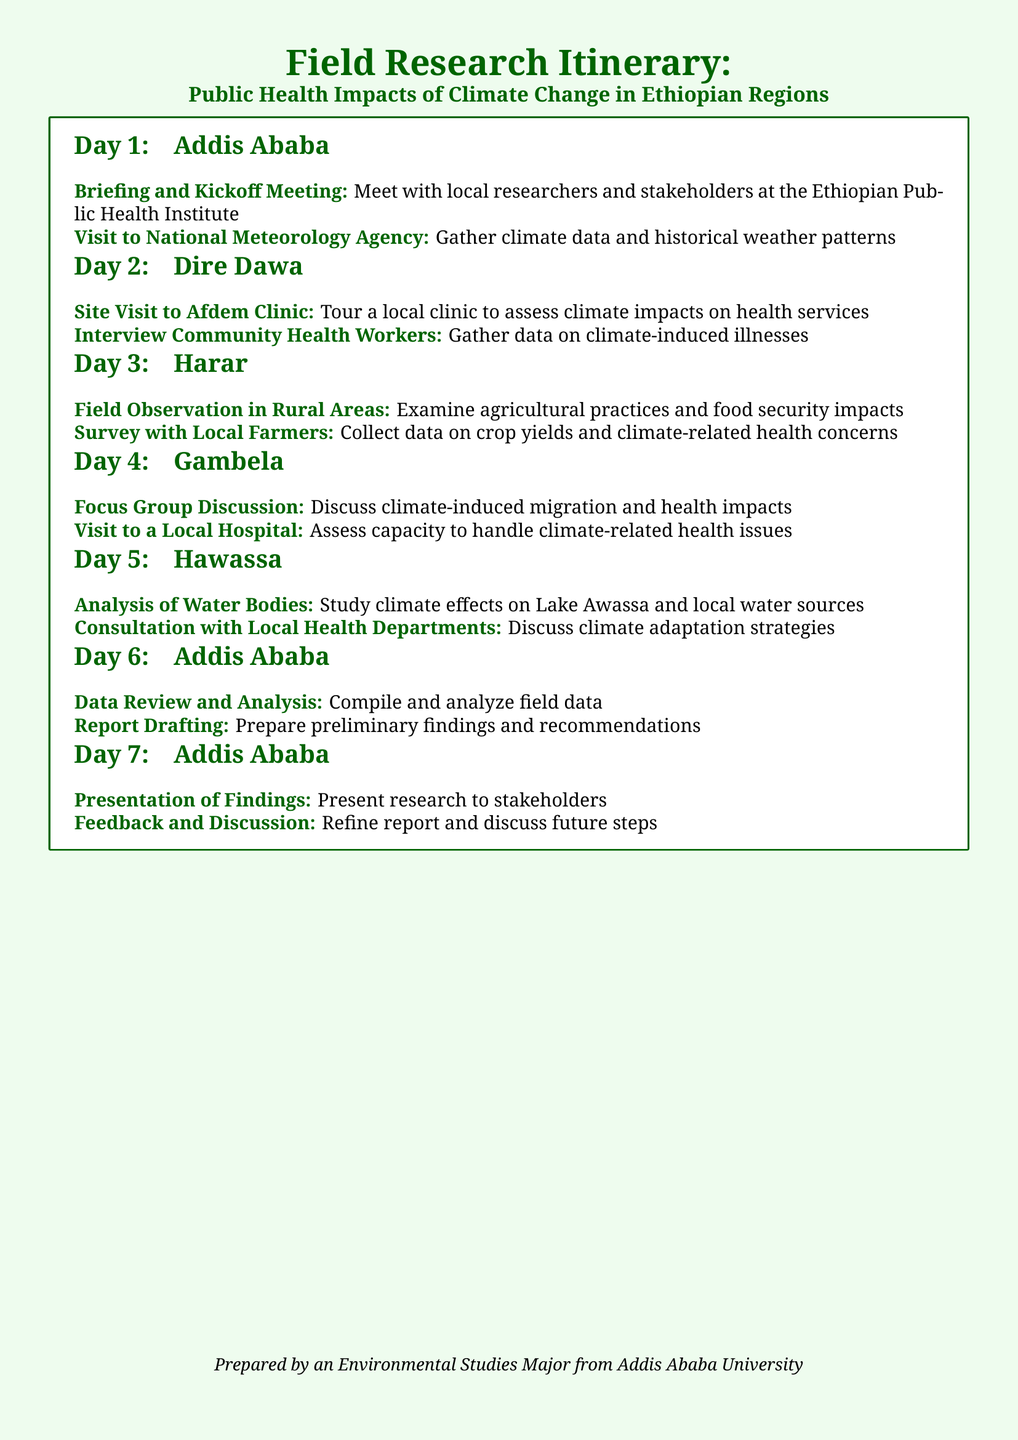What is the first activity scheduled in Addis Ababa? The first activity listed under Addis Ababa is the Briefing and Kickoff Meeting with local researchers and stakeholders.
Answer: Briefing and Kickoff Meeting How many locations are included in the itinerary? The document mentions six locations where activities are planned: Addis Ababa, Dire Dawa, Harar, Gambela, Hawassa, and another session in Addis Ababa.
Answer: Six locations What type of data is gathered at the National Meteorology Agency? The National Meteorology Agency is associated with climate data and historical weather patterns collection as stated in the document.
Answer: Climate data Which local community is visited in Dire Dawa? The Afdem Clinic is specifically mentioned as the clinic to be visited for assessing climate impacts on health services.
Answer: Afdem Clinic What is the main topic discussed during the Focus Group Discussion in Gambela? The main topic for discussion revolves around climate-induced migration and health impacts as per the itinerary.
Answer: Climate-induced migration What specific health-related aspect is analyzed in Hawassa? The document specifies that the analysis of water bodies in relation to climate effects is the focus in Hawassa.
Answer: Climate effects on Lake Awassa How many activities are scheduled on the final day in Addis Ababa? On the final day in Addis Ababa, there are two activities planned: Presentation of Findings and Feedback and Discussion.
Answer: Two activities What type of local practitioners are interviewed in Dire Dawa? Community Health Workers are specifically noted as the practitioners to be interviewed for gathering data on climate-induced illnesses.
Answer: Community Health Workers What is the last phase of the research itinerary? The last phase mentioned involves the Presentation of Findings, which is a significant concluding activity.
Answer: Presentation of Findings 